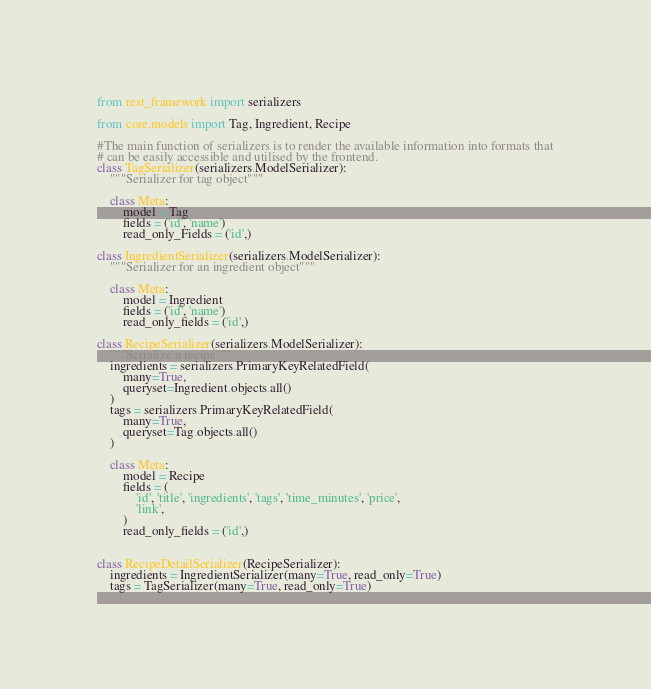<code> <loc_0><loc_0><loc_500><loc_500><_Python_>from rest_framework import serializers

from core.models import Tag, Ingredient, Recipe

#The main function of serializers is to render the available information into formats that
# can be easily accessible and utilised by the frontend.
class TagSerializer(serializers.ModelSerializer):
    """Serializer for tag object"""

    class Meta:
        model = Tag
        fields = ('id', 'name')
        read_only_Fields = ('id',)

class IngredientSerializer(serializers.ModelSerializer):
    """Serializer for an ingredient object"""

    class Meta:
        model = Ingredient
        fields = ('id', 'name')
        read_only_fields = ('id',)      

class RecipeSerializer(serializers.ModelSerializer):
    """Serialize a recipe"""
    ingredients = serializers.PrimaryKeyRelatedField(
        many=True,
        queryset=Ingredient.objects.all()
    )
    tags = serializers.PrimaryKeyRelatedField(
        many=True,
        queryset=Tag.objects.all()
    )

    class Meta:
        model = Recipe
        fields = (
            'id', 'title', 'ingredients', 'tags', 'time_minutes', 'price',
            'link',
        )
        read_only_fields = ('id',)
        
        
class RecipeDetailSerializer(RecipeSerializer):
    ingredients = IngredientSerializer(many=True, read_only=True)
    tags = TagSerializer(many=True, read_only=True)                 </code> 